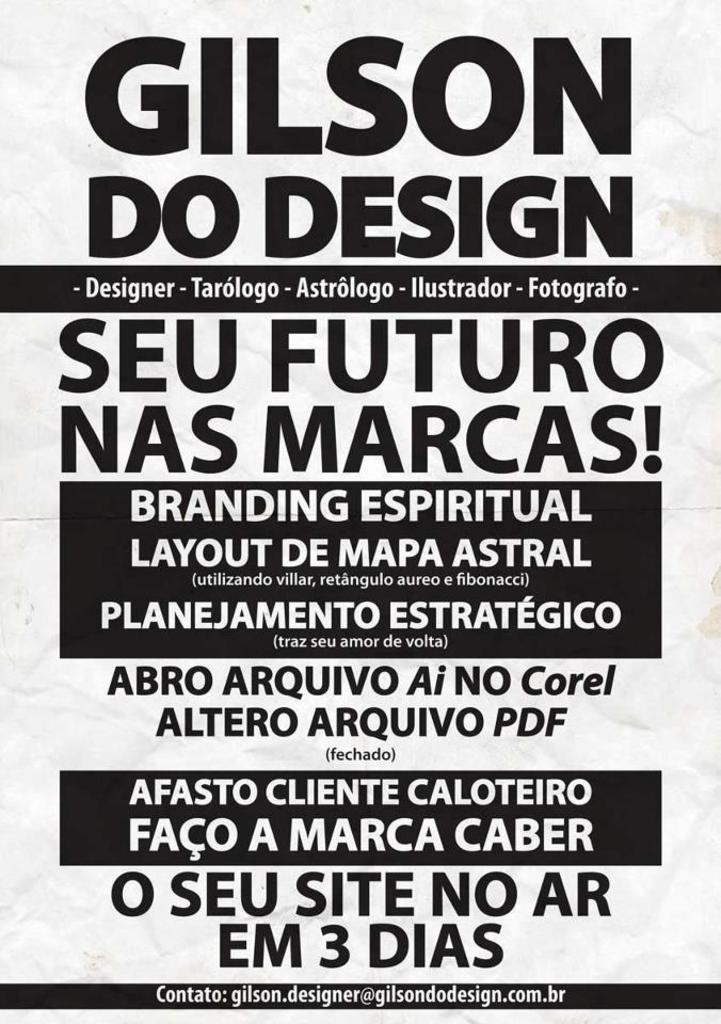What is present in the image that is related to advertising or information? There is a poster in the image. What is the color of the poster? The poster is white in color. What can be seen on the poster besides its color? There is text written on the poster. What is the color of the text on the poster? The text is in black color. Can you see any cows in the image? No, there are no cows present in the image. Is the poster emitting steam in the image? No, the poster is not emitting steam in the image. 